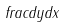<formula> <loc_0><loc_0><loc_500><loc_500>f r a c d y d x</formula> 